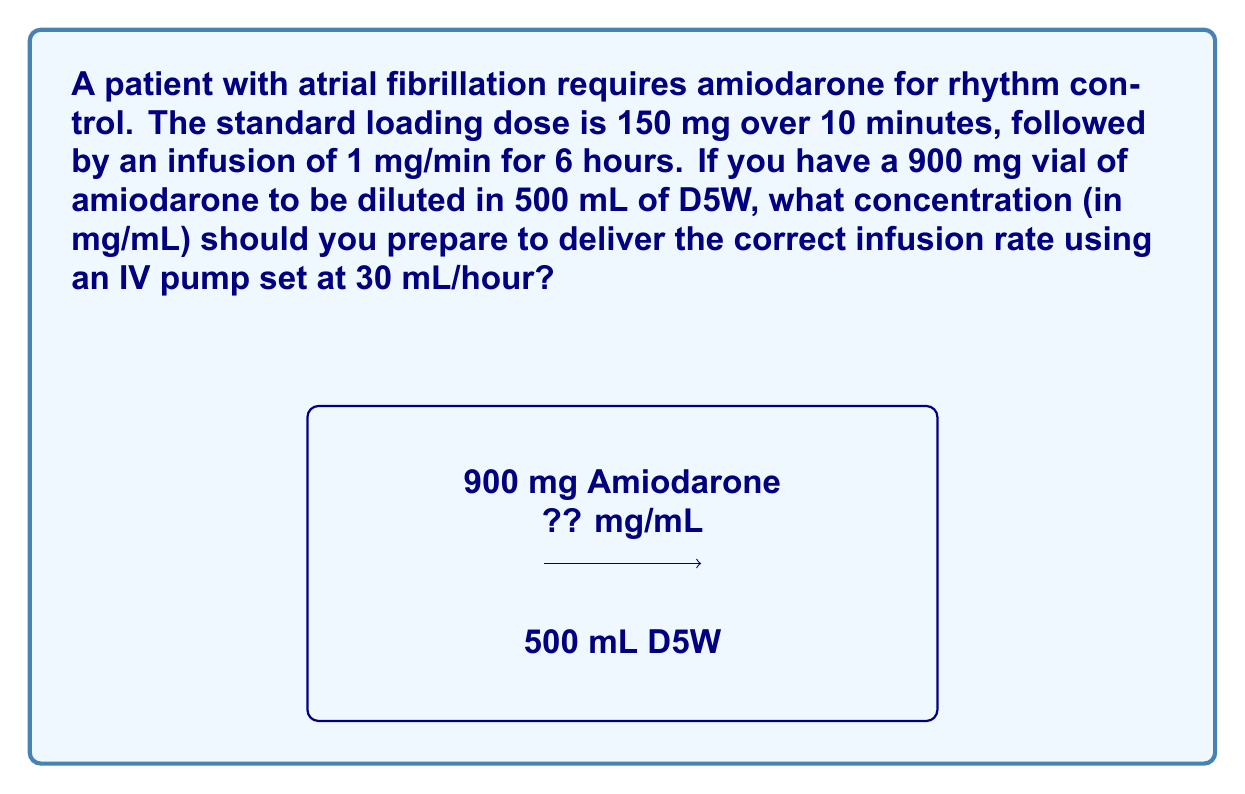Can you answer this question? Let's approach this step-by-step:

1) First, we need to determine the total amount of amiodarone needed for the infusion:
   $$\text{Infusion amount} = 1 \text{ mg/min} \times 60 \text{ min/hour} \times 6 \text{ hours} = 360 \text{ mg}$$

2) Now, we need to calculate the concentration of the solution:
   $$\text{Concentration} = \frac{\text{Total drug amount}}{\text{Total volume}}$$

3) We have 900 mg of amiodarone in 500 mL of D5W:
   $$\text{Concentration} = \frac{900 \text{ mg}}{500 \text{ mL}} = 1.8 \text{ mg/mL}$$

4) Now, we need to check if this concentration will deliver the correct infusion rate:
   $$\text{Infusion rate} = 30 \text{ mL/hour} \times 1.8 \text{ mg/mL} = 54 \text{ mg/hour}$$

5) Convert this to mg/min:
   $$54 \text{ mg/hour} \div 60 \text{ min/hour} = 0.9 \text{ mg/min}$$

6) This is close to our target of 1 mg/min, but not exact. To get exactly 1 mg/min with a pump rate of 30 mL/hour, we need:
   $$\text{Required concentration} = \frac{1 \text{ mg/min}}{30 \text{ mL/hour}} \times 60 \text{ min/hour} = 2 \text{ mg/mL}$$

Therefore, we need to prepare a solution with a concentration of 2 mg/mL.
Answer: 2 mg/mL 